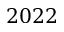Convert formula to latex. <formula><loc_0><loc_0><loc_500><loc_500>2 0 2 2</formula> 